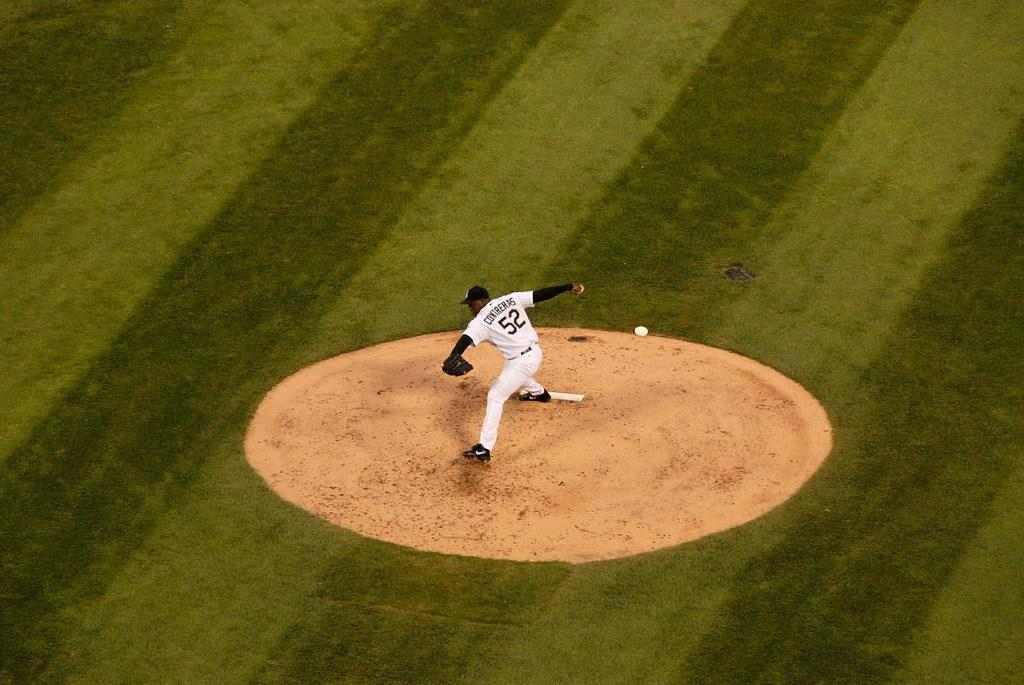<image>
Present a compact description of the photo's key features. Pitcher number 52 throws a pitch to a batter. 